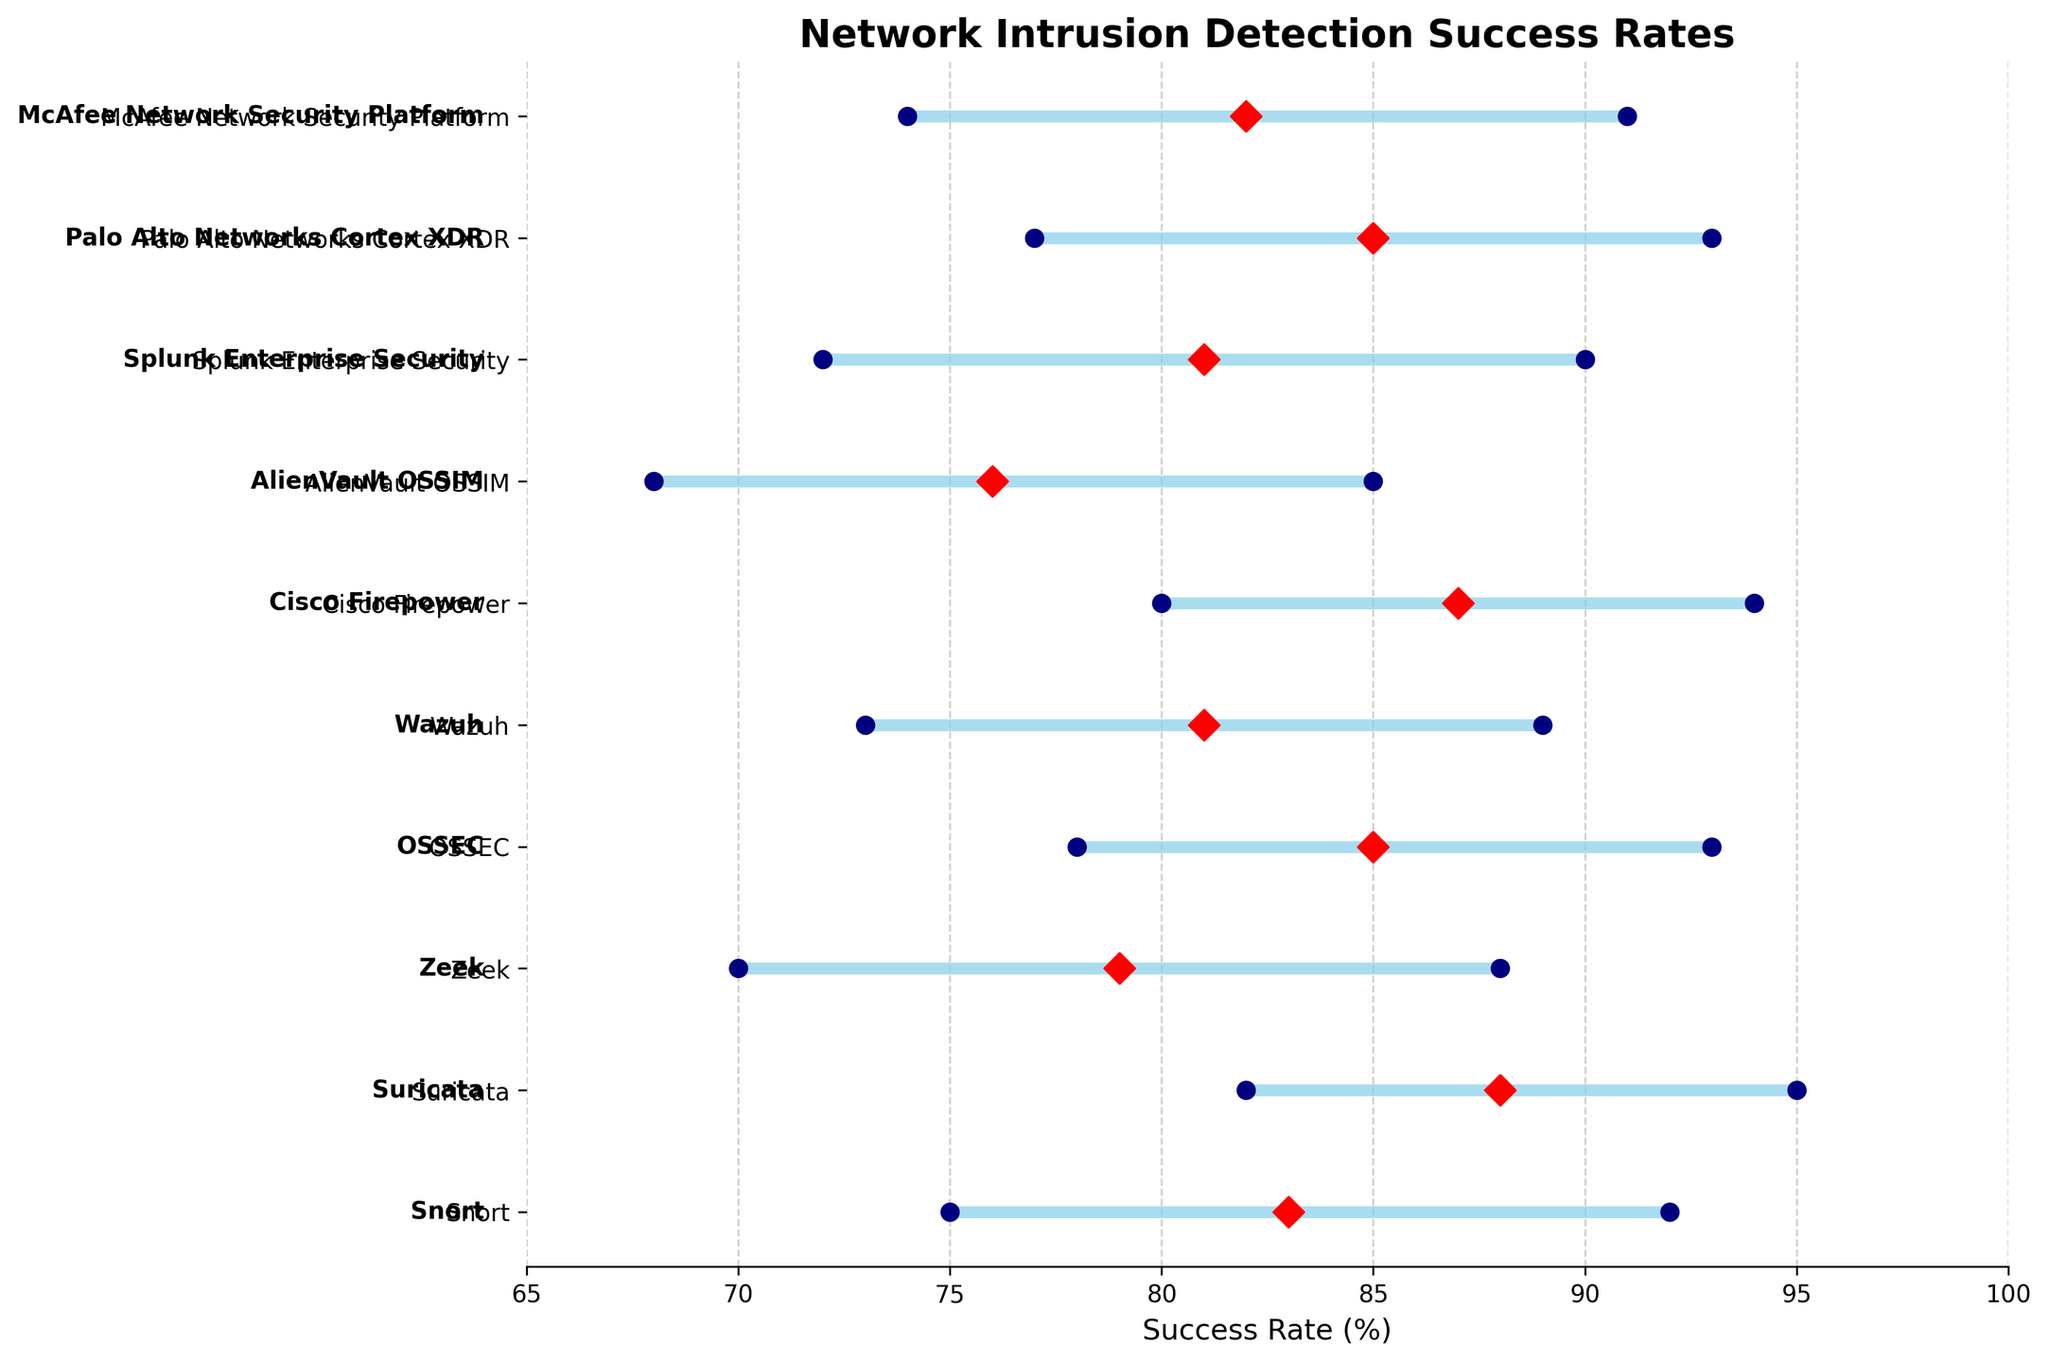What is the title of the plot? The title can be found at the top of the plot, which usually summarizes the main theme or data being represented.
Answer: Network Intrusion Detection Success Rates Which security tool has the highest average success rate for detecting DDoS attacks? Look for the tool associated with the DDoS threat type and check its average success rate, marked by a red diamond.
Answer: Suricata What is the range of success rates for AlienVault OSSIM in detecting Zero-Day Exploits? Find the minimum and maximum success rate values for the AlienVault OSSIM tool associated with Zero-Day Exploits. The range is the difference between these values.
Answer: 68-85% What is the difference between the maximum and minimum success rates for McAfee Network Security Platform? Locate the maximum and minimum success rate values for McAfee Network Security Platform and subtract the minimum from the maximum to get the difference.
Answer: 17% Which security tool has the lowest minimum success rate, and what is the rate? Scan all the tools and identify the one with the smallest minimum success rate, which is marked by a navy blue dot on the left.
Answer: AlienVault OSSIM, 68% Between Snort and Zeek, which has a higher average success rate for their respective threat types? Compare the average success rates (red diamonds) for Snort and Zeek to determine which one is higher.
Answer: Snort What is the average success rate for OSSEC in detecting Brute Force attacks? Find OSSEC's red diamond marker, representing the average success rate, and read the value next to it.
Answer: 85% Which tool shows the smallest range in success rates for its respective threat type? Calculate the range of success rates (Max - Min) for each tool and find the smallest value.
Answer: Suricata How many different threat types are represented in the plot? Count the unique threat types listed alongside the security tools on the left axis.
Answer: 10 How does the success rate range of Wazuh compare to that of Splunk Enterprise Security in detecting their respective threats? Examine the minimum and maximum success rates for both Wazuh and Splunk Enterprise Security and compare the spans covered by their success rates.
Answer: Both have a range of 16% 